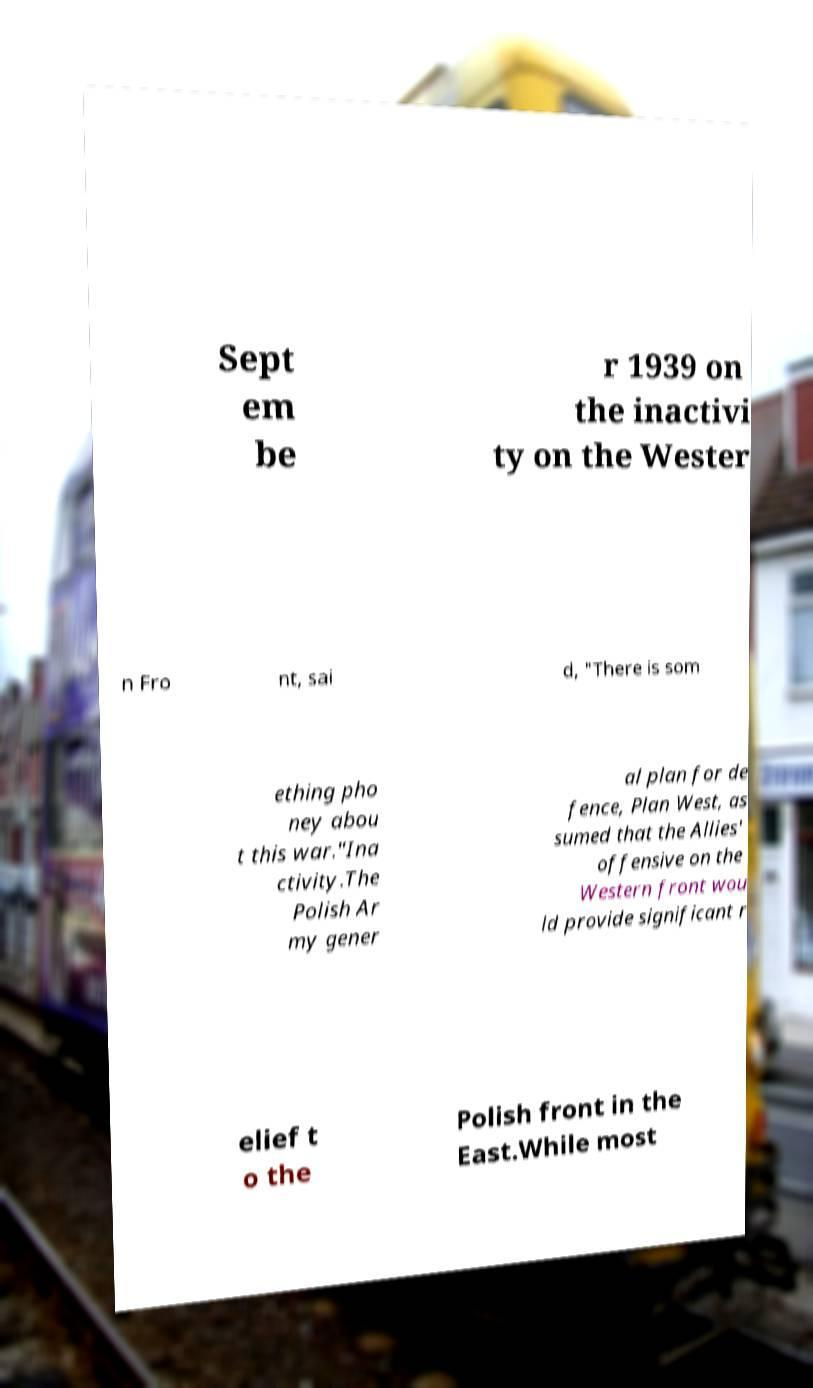Can you read and provide the text displayed in the image?This photo seems to have some interesting text. Can you extract and type it out for me? Sept em be r 1939 on the inactivi ty on the Wester n Fro nt, sai d, "There is som ething pho ney abou t this war."Ina ctivity.The Polish Ar my gener al plan for de fence, Plan West, as sumed that the Allies' offensive on the Western front wou ld provide significant r elief t o the Polish front in the East.While most 